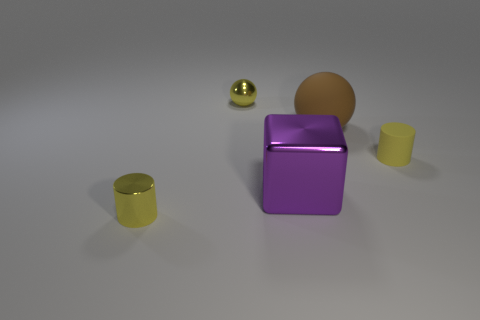Add 2 large red metallic balls. How many objects exist? 7 Subtract all cubes. How many objects are left? 4 Subtract 0 red cylinders. How many objects are left? 5 Subtract all small blue shiny cylinders. Subtract all big purple metallic cubes. How many objects are left? 4 Add 2 large purple cubes. How many large purple cubes are left? 3 Add 3 large purple shiny things. How many large purple shiny things exist? 4 